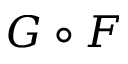<formula> <loc_0><loc_0><loc_500><loc_500>G \circ F</formula> 